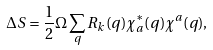<formula> <loc_0><loc_0><loc_500><loc_500>\Delta S = \frac { 1 } { 2 } \Omega \sum _ { q } R _ { k } ( q ) \chi _ { a } ^ { \ast } ( q ) \chi ^ { a } ( q ) ,</formula> 